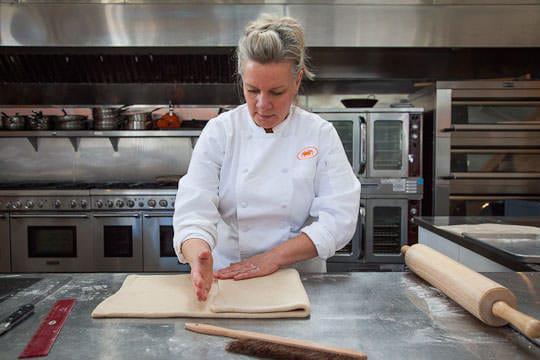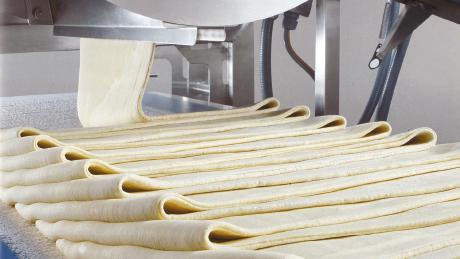The first image is the image on the left, the second image is the image on the right. Assess this claim about the two images: "A single person is working with dough in the image on the left.". Correct or not? Answer yes or no. Yes. The first image is the image on the left, the second image is the image on the right. Assess this claim about the two images: "One image shows a single sheet of puff pastry with three folds visible.". Correct or not? Answer yes or no. No. 